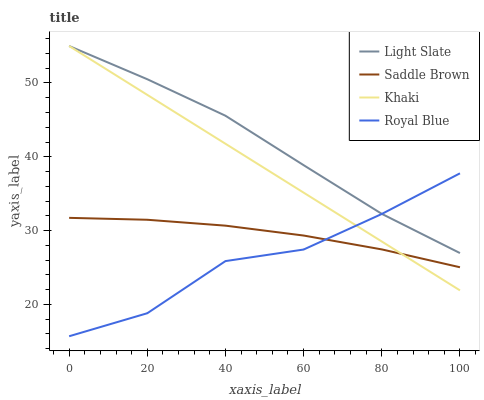Does Royal Blue have the minimum area under the curve?
Answer yes or no. Yes. Does Light Slate have the maximum area under the curve?
Answer yes or no. Yes. Does Khaki have the minimum area under the curve?
Answer yes or no. No. Does Khaki have the maximum area under the curve?
Answer yes or no. No. Is Khaki the smoothest?
Answer yes or no. Yes. Is Royal Blue the roughest?
Answer yes or no. Yes. Is Royal Blue the smoothest?
Answer yes or no. No. Is Khaki the roughest?
Answer yes or no. No. Does Royal Blue have the lowest value?
Answer yes or no. Yes. Does Khaki have the lowest value?
Answer yes or no. No. Does Khaki have the highest value?
Answer yes or no. Yes. Does Royal Blue have the highest value?
Answer yes or no. No. Is Saddle Brown less than Light Slate?
Answer yes or no. Yes. Is Light Slate greater than Saddle Brown?
Answer yes or no. Yes. Does Royal Blue intersect Light Slate?
Answer yes or no. Yes. Is Royal Blue less than Light Slate?
Answer yes or no. No. Is Royal Blue greater than Light Slate?
Answer yes or no. No. Does Saddle Brown intersect Light Slate?
Answer yes or no. No. 